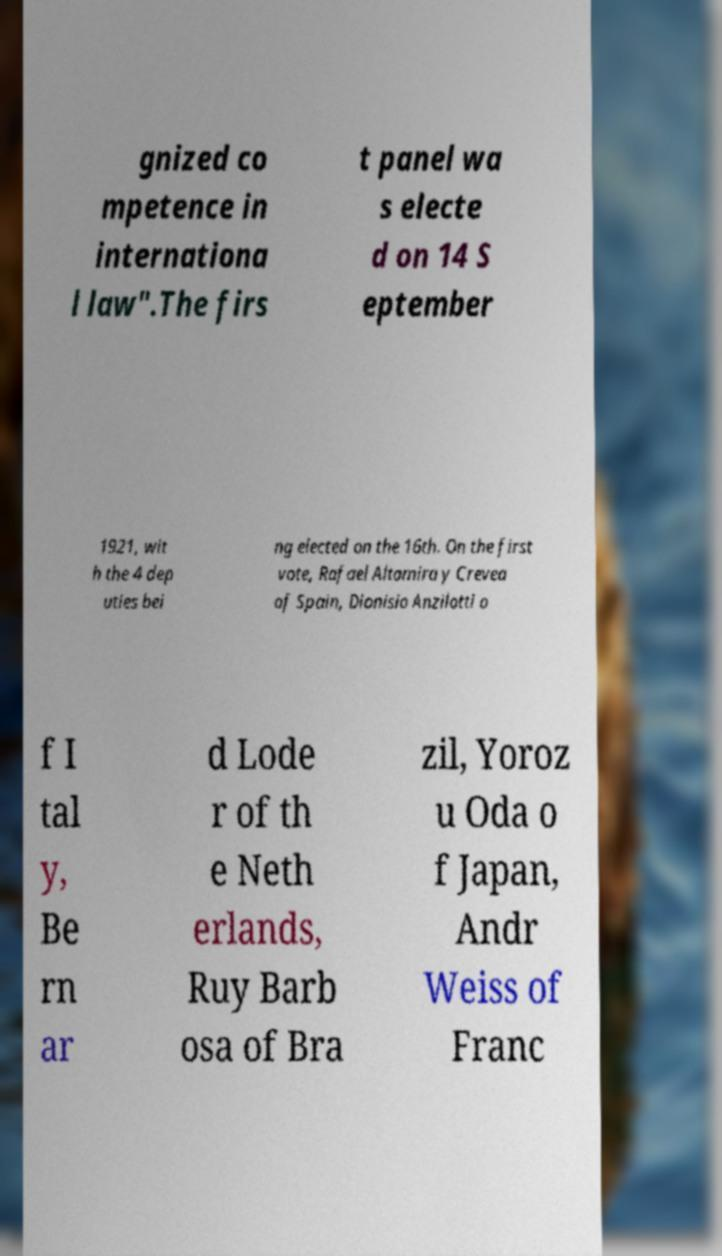Please identify and transcribe the text found in this image. gnized co mpetence in internationa l law".The firs t panel wa s electe d on 14 S eptember 1921, wit h the 4 dep uties bei ng elected on the 16th. On the first vote, Rafael Altamira y Crevea of Spain, Dionisio Anzilotti o f I tal y, Be rn ar d Lode r of th e Neth erlands, Ruy Barb osa of Bra zil, Yoroz u Oda o f Japan, Andr Weiss of Franc 